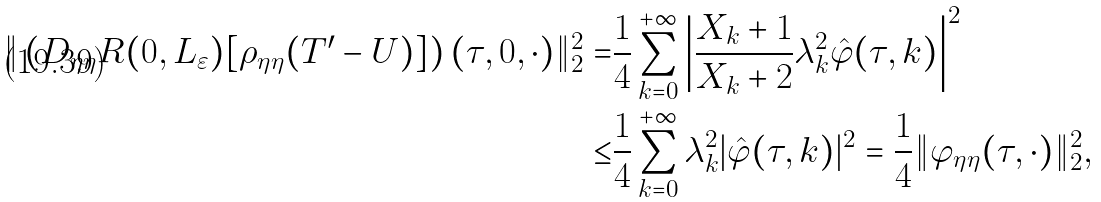Convert formula to latex. <formula><loc_0><loc_0><loc_500><loc_500>\| \left ( D _ { \eta \eta } R ( 0 , L _ { \varepsilon } ) [ \rho _ { \eta \eta } ( { T } ^ { \prime } - { U } ) ] \right ) ( \tau , 0 , \cdot ) \| _ { 2 } ^ { 2 } = & \frac { 1 } { 4 } \sum _ { k = 0 } ^ { + \infty } \left | \frac { X _ { k } + 1 } { X _ { k } + 2 } \lambda _ { k } ^ { 2 } \hat { \varphi } ( \tau , k ) \right | ^ { 2 } \\ \leq & \frac { 1 } { 4 } \sum _ { k = 0 } ^ { + \infty } \lambda _ { k } ^ { 2 } | \hat { \varphi } ( \tau , k ) | ^ { 2 } = \frac { 1 } { 4 } \| \varphi _ { \eta \eta } ( \tau , \cdot ) \| _ { 2 } ^ { 2 } ,</formula> 